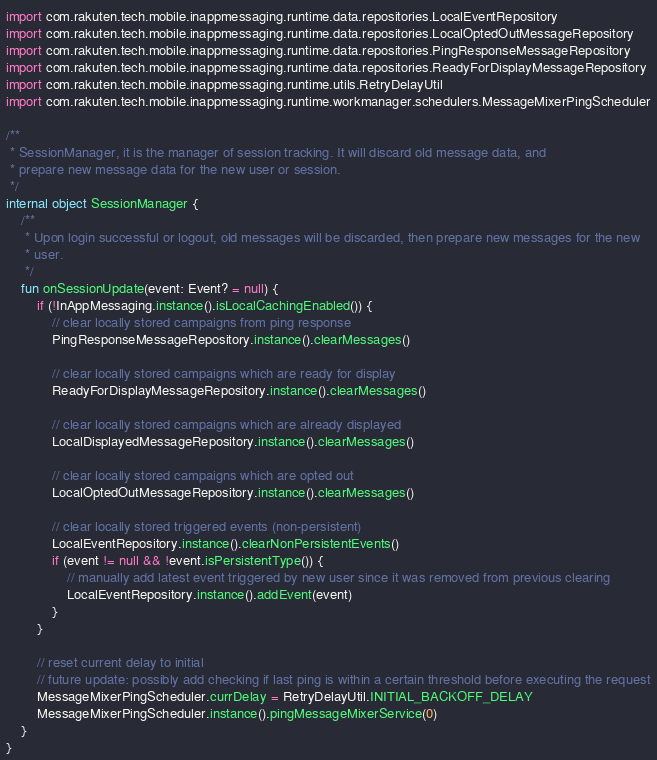<code> <loc_0><loc_0><loc_500><loc_500><_Kotlin_>import com.rakuten.tech.mobile.inappmessaging.runtime.data.repositories.LocalEventRepository
import com.rakuten.tech.mobile.inappmessaging.runtime.data.repositories.LocalOptedOutMessageRepository
import com.rakuten.tech.mobile.inappmessaging.runtime.data.repositories.PingResponseMessageRepository
import com.rakuten.tech.mobile.inappmessaging.runtime.data.repositories.ReadyForDisplayMessageRepository
import com.rakuten.tech.mobile.inappmessaging.runtime.utils.RetryDelayUtil
import com.rakuten.tech.mobile.inappmessaging.runtime.workmanager.schedulers.MessageMixerPingScheduler

/**
 * SessionManager, it is the manager of session tracking. It will discard old message data, and
 * prepare new message data for the new user or session.
 */
internal object SessionManager {
    /**
     * Upon login successful or logout, old messages will be discarded, then prepare new messages for the new
     * user.
     */
    fun onSessionUpdate(event: Event? = null) {
        if (!InAppMessaging.instance().isLocalCachingEnabled()) {
            // clear locally stored campaigns from ping response
            PingResponseMessageRepository.instance().clearMessages()

            // clear locally stored campaigns which are ready for display
            ReadyForDisplayMessageRepository.instance().clearMessages()

            // clear locally stored campaigns which are already displayed
            LocalDisplayedMessageRepository.instance().clearMessages()

            // clear locally stored campaigns which are opted out
            LocalOptedOutMessageRepository.instance().clearMessages()

            // clear locally stored triggered events (non-persistent)
            LocalEventRepository.instance().clearNonPersistentEvents()
            if (event != null && !event.isPersistentType()) {
                // manually add latest event triggered by new user since it was removed from previous clearing
                LocalEventRepository.instance().addEvent(event)
            }
        }

        // reset current delay to initial
        // future update: possibly add checking if last ping is within a certain threshold before executing the request
        MessageMixerPingScheduler.currDelay = RetryDelayUtil.INITIAL_BACKOFF_DELAY
        MessageMixerPingScheduler.instance().pingMessageMixerService(0)
    }
}
</code> 